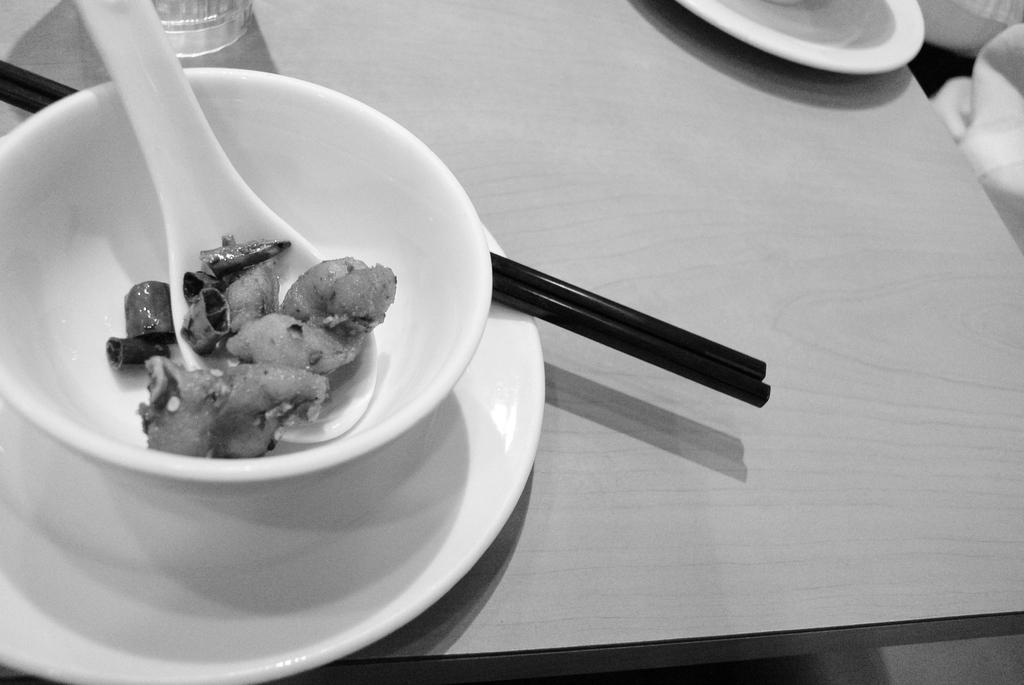What type of food can be seen in the image? There is food in the image, but the specific type cannot be determined from the facts provided. What utensil is present in the image? There is a spoon in the image. What is the food contained in? There is a bowl in the image. What is the food served on? There is a plate in the image. What other utensil is present in the image? There are chopsticks in the image. What beverage container is present in the image? There is a glass in the image. Where are all these items located? All of these items are on a table. What type of camera is visible in the image? There is no camera present in the image. What type of connection can be seen between the food and the plate in the image? There is no visible connection between the food and the plate in the image; they are simply placed on the plate. 